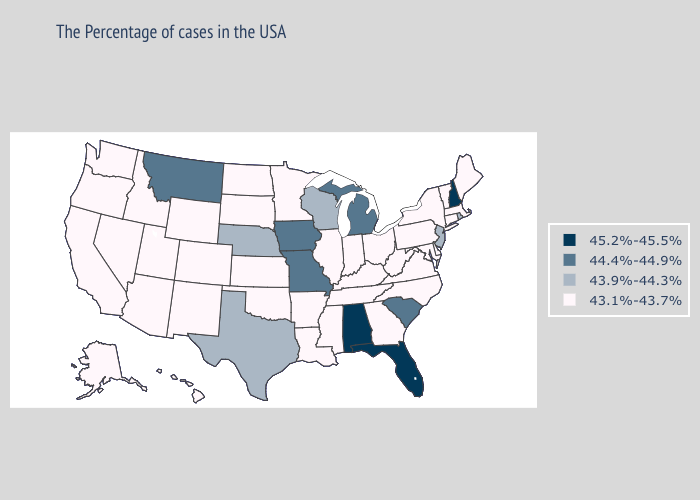Name the states that have a value in the range 43.1%-43.7%?
Be succinct. Maine, Massachusetts, Vermont, Connecticut, New York, Delaware, Maryland, Pennsylvania, Virginia, North Carolina, West Virginia, Ohio, Georgia, Kentucky, Indiana, Tennessee, Illinois, Mississippi, Louisiana, Arkansas, Minnesota, Kansas, Oklahoma, South Dakota, North Dakota, Wyoming, Colorado, New Mexico, Utah, Arizona, Idaho, Nevada, California, Washington, Oregon, Alaska, Hawaii. What is the lowest value in the South?
Write a very short answer. 43.1%-43.7%. What is the highest value in states that border Oklahoma?
Write a very short answer. 44.4%-44.9%. Does Arkansas have a higher value than Washington?
Write a very short answer. No. Does the first symbol in the legend represent the smallest category?
Keep it brief. No. How many symbols are there in the legend?
Quick response, please. 4. Does the first symbol in the legend represent the smallest category?
Give a very brief answer. No. What is the value of Nebraska?
Short answer required. 43.9%-44.3%. Name the states that have a value in the range 44.4%-44.9%?
Be succinct. South Carolina, Michigan, Missouri, Iowa, Montana. Does Vermont have a lower value than Pennsylvania?
Answer briefly. No. What is the lowest value in states that border Colorado?
Keep it brief. 43.1%-43.7%. Among the states that border New Jersey , which have the highest value?
Concise answer only. New York, Delaware, Pennsylvania. Among the states that border Missouri , which have the lowest value?
Concise answer only. Kentucky, Tennessee, Illinois, Arkansas, Kansas, Oklahoma. Does Montana have the lowest value in the West?
Answer briefly. No. 